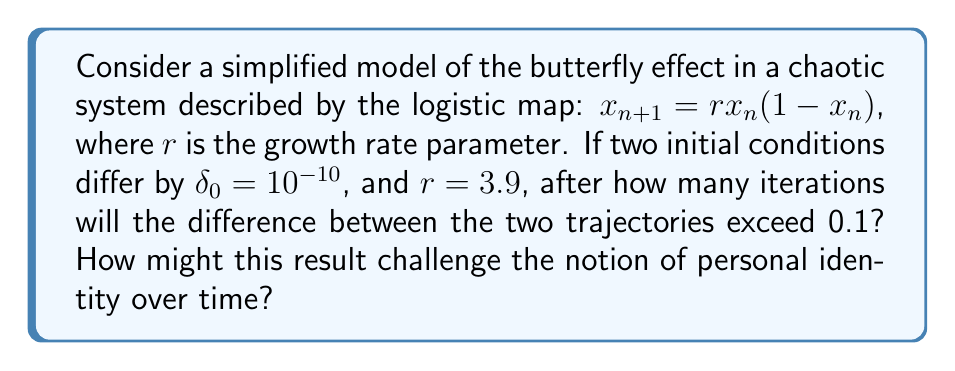Provide a solution to this math problem. 1) The logistic map is a discrete-time demographic model that exhibits chaotic behavior for certain parameter values.

2) For $r = 3.9$, the system is in the chaotic regime.

3) Let's denote the two initial conditions as $x_0$ and $y_0 = x_0 + \delta_0$.

4) The difference between trajectories after $n$ iterations is given by:

   $\delta_n \approx \delta_0 e^{\lambda n}$

   where $\lambda$ is the Lyapunov exponent.

5) For $r = 3.9$, the Lyapunov exponent is approximately $\lambda \approx 0.6$.

6) We want to find $n$ such that $\delta_n > 0.1$:

   $10^{-10} e^{0.6n} > 0.1$

7) Taking natural logarithms of both sides:

   $\ln(10^{-10}) + 0.6n > \ln(0.1)$

8) Solving for $n$:

   $0.6n > \ln(0.1) - \ln(10^{-10})$
   $0.6n > -2.3 + 23$
   $0.6n > 20.7$
   $n > 34.5$

9) The smallest integer $n$ that satisfies this inequality is 35.

This result challenges the notion of personal identity over time by illustrating how small, imperceptible differences can lead to dramatically divergent outcomes in a short period. In the context of personal identity, it suggests that minute variations in experiences or decisions could potentially result in significantly different "versions" of an individual over time, questioning the continuity and stability of personal identity.
Answer: 35 iterations 